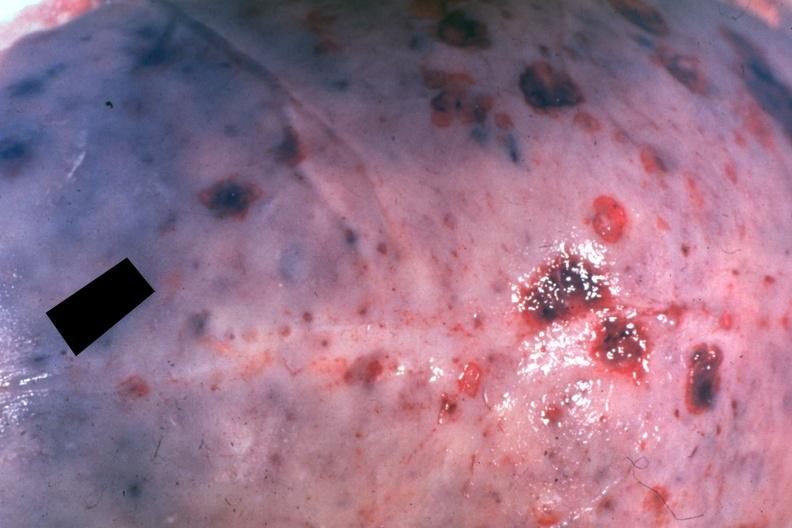what is present?
Answer the question using a single word or phrase. Lymphoma 